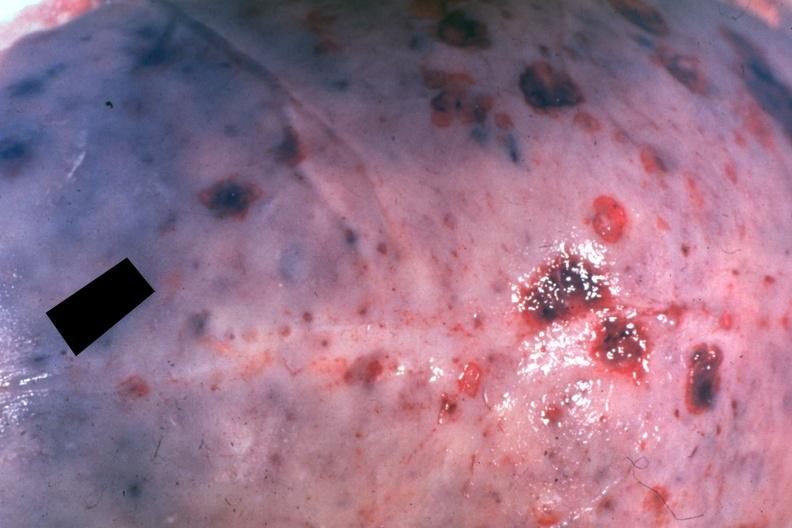what is present?
Answer the question using a single word or phrase. Lymphoma 